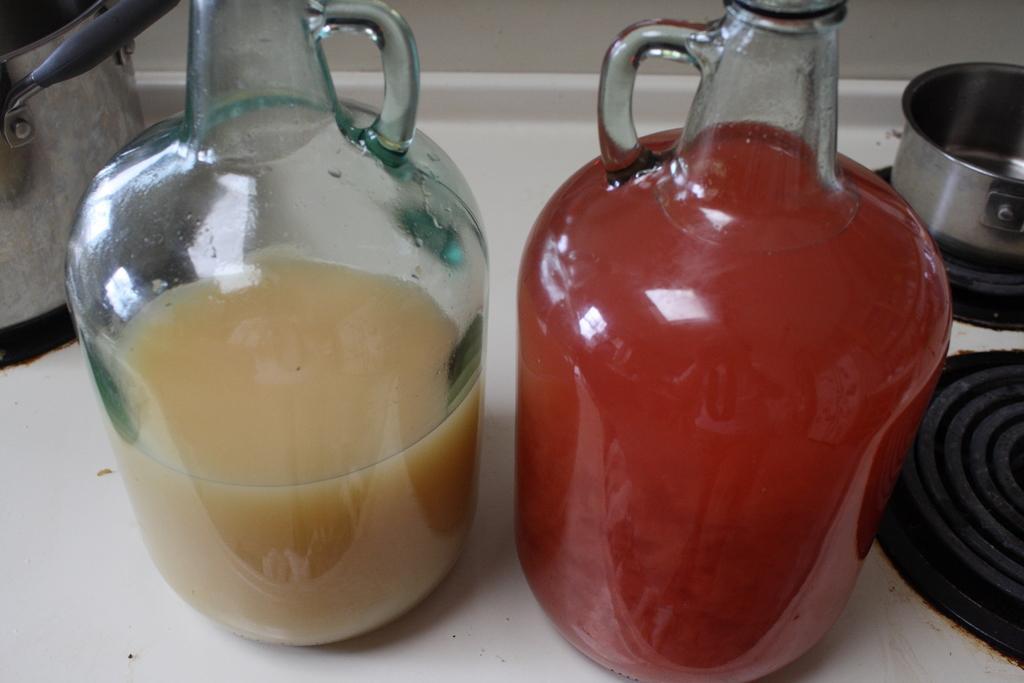Describe this image in one or two sentences. In the image we can see there are two jars of juices kept on the gas stove and behind there are vessels kept on the gas stove. 